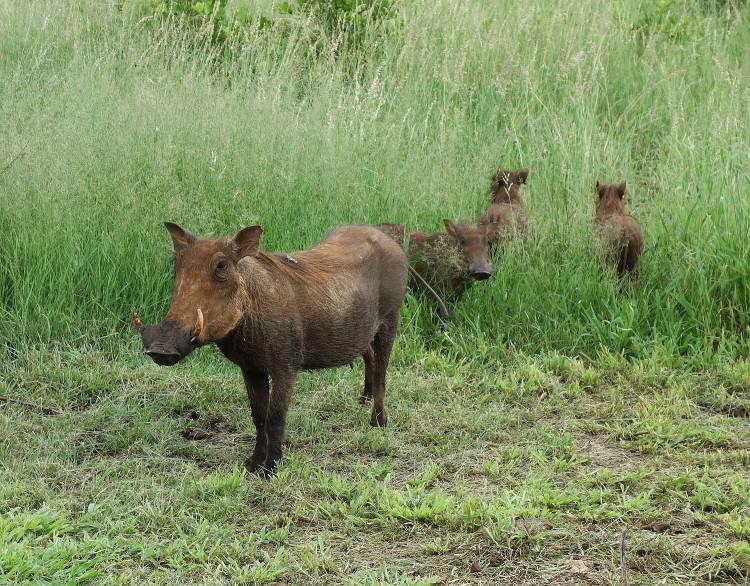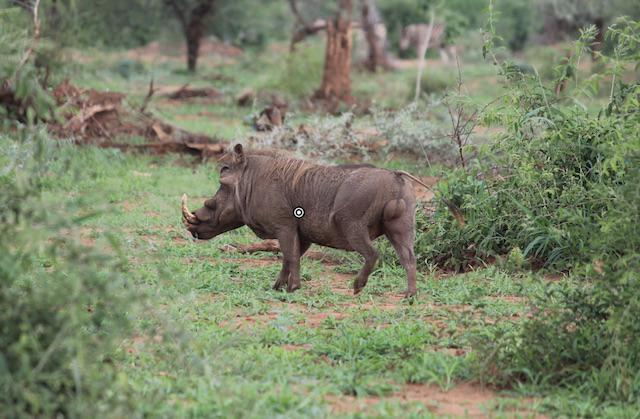The first image is the image on the left, the second image is the image on the right. Assess this claim about the two images: "There are 3 warthogs in the image pair". Correct or not? Answer yes or no. No. 